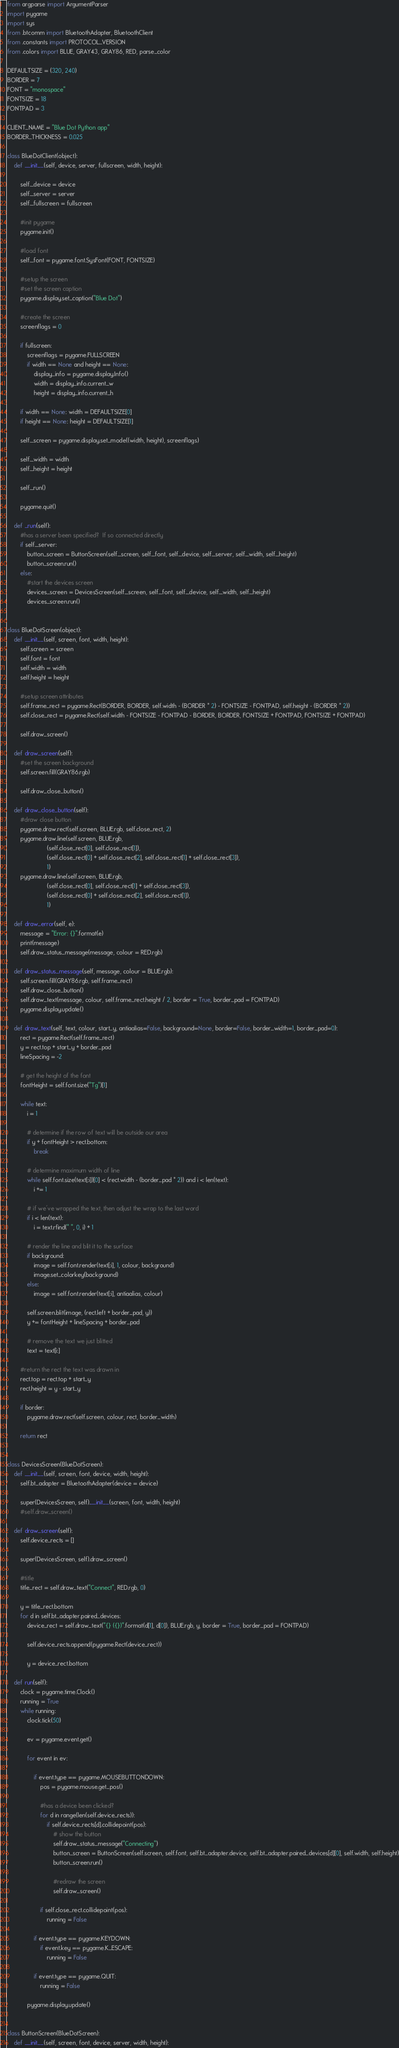Convert code to text. <code><loc_0><loc_0><loc_500><loc_500><_Python_>from argparse import ArgumentParser
import pygame
import sys
from .btcomm import BluetoothAdapter, BluetoothClient
from .constants import PROTOCOL_VERSION
from .colors import BLUE, GRAY43, GRAY86, RED, parse_color

DEFAULTSIZE = (320, 240)
BORDER = 7
FONT = "monospace"
FONTSIZE = 18
FONTPAD = 3

CLIENT_NAME = "Blue Dot Python app"
BORDER_THICKNESS = 0.025

class BlueDotClient(object):
    def __init__(self, device, server, fullscreen, width, height):

        self._device = device
        self._server = server
        self._fullscreen = fullscreen
        
        #init pygame
        pygame.init()

        #load font
        self._font = pygame.font.SysFont(FONT, FONTSIZE)

        #setup the screen
        #set the screen caption
        pygame.display.set_caption("Blue Dot")

        #create the screen
        screenflags = 0

        if fullscreen:
            screenflags = pygame.FULLSCREEN
            if width == None and height == None:
                display_info = pygame.display.Info()
                width = display_info.current_w
                height = display_info.current_h

        if width == None: width = DEFAULTSIZE[0]
        if height == None: height = DEFAULTSIZE[1]

        self._screen = pygame.display.set_mode((width, height), screenflags)

        self._width = width
        self._height = height

        self._run()

        pygame.quit()

    def _run(self):
        #has a server been specified?  If so connected directly
        if self._server:
            button_screen = ButtonScreen(self._screen, self._font, self._device, self._server, self._width, self._height)
            button_screen.run()
        else:
            #start the devices screen
            devices_screen = DevicesScreen(self._screen, self._font, self._device, self._width, self._height)
            devices_screen.run()


class BlueDotScreen(object):
    def __init__(self, screen, font, width, height):
        self.screen = screen
        self.font = font
        self.width = width
        self.height = height

        #setup screen attributes
        self.frame_rect = pygame.Rect(BORDER, BORDER, self.width - (BORDER * 2) - FONTSIZE - FONTPAD, self.height - (BORDER * 2))
        self.close_rect = pygame.Rect(self.width - FONTSIZE - FONTPAD - BORDER, BORDER, FONTSIZE + FONTPAD, FONTSIZE + FONTPAD)

        self.draw_screen()

    def draw_screen(self):
        #set the screen background
        self.screen.fill(GRAY86.rgb)

        self.draw_close_button()

    def draw_close_button(self):
        #draw close button
        pygame.draw.rect(self.screen, BLUE.rgb, self.close_rect, 2)
        pygame.draw.line(self.screen, BLUE.rgb,
                        (self.close_rect[0], self.close_rect[1]),
                        (self.close_rect[0] + self.close_rect[2], self.close_rect[1] + self.close_rect[3]),
                        1)
        pygame.draw.line(self.screen, BLUE.rgb,
                        (self.close_rect[0], self.close_rect[1] + self.close_rect[3]),
                        (self.close_rect[0] + self.close_rect[2], self.close_rect[1]),
                        1)

    def draw_error(self, e):
        message = "Error: {}".format(e)
        print(message)
        self.draw_status_message(message, colour = RED.rgb)

    def draw_status_message(self, message, colour = BLUE.rgb):
        self.screen.fill(GRAY86.rgb, self.frame_rect)
        self.draw_close_button()
        self.draw_text(message, colour, self.frame_rect.height / 2, border = True, border_pad = FONTPAD)
        pygame.display.update()

    def draw_text(self, text, colour, start_y, antiaalias=False, background=None, border=False, border_width=1, border_pad=0):
        rect = pygame.Rect(self.frame_rect)
        y = rect.top + start_y + border_pad
        lineSpacing = -2

        # get the height of the font
        fontHeight = self.font.size("Tg")[1]

        while text:
            i = 1

            # determine if the row of text will be outside our area
            if y + fontHeight > rect.bottom:
                break

            # determine maximum width of line
            while self.font.size(text[:i])[0] < (rect.width - (border_pad * 2)) and i < len(text):
                i += 1

            # if we've wrapped the text, then adjust the wrap to the last word
            if i < len(text):
                i = text.rfind(" ", 0, i) + 1

            # render the line and blit it to the surface
            if background:
                image = self.font.render(text[:i], 1, colour, background)
                image.set_colorkey(background)
            else:
                image = self.font.render(text[:i], antiaalias, colour)

            self.screen.blit(image, (rect.left + border_pad, y))
            y += fontHeight + lineSpacing + border_pad

            # remove the text we just blitted
            text = text[i:]

        #return the rect the text was drawn in
        rect.top = rect.top + start_y
        rect.height = y - start_y

        if border:
            pygame.draw.rect(self.screen, colour, rect, border_width)

        return rect


class DevicesScreen(BlueDotScreen):
    def __init__(self, screen, font, device, width, height):
        self.bt_adapter = BluetoothAdapter(device = device)

        super(DevicesScreen, self).__init__(screen, font, width, height)
        #self.draw_screen()

    def draw_screen(self):
        self.device_rects = []

        super(DevicesScreen, self).draw_screen()

        #title
        title_rect = self.draw_text("Connect", RED.rgb, 0)

        y = title_rect.bottom
        for d in self.bt_adapter.paired_devices:
            device_rect = self.draw_text("{} ({})".format(d[1], d[0]), BLUE.rgb, y, border = True, border_pad = FONTPAD)

            self.device_rects.append(pygame.Rect(device_rect))

            y = device_rect.bottom

    def run(self):
        clock = pygame.time.Clock()
        running = True
        while running:
            clock.tick(50)

            ev = pygame.event.get()

            for event in ev:

                if event.type == pygame.MOUSEBUTTONDOWN:
                    pos = pygame.mouse.get_pos()

                    #has a device been clicked?
                    for d in range(len(self.device_rects)):
                        if self.device_rects[d].collidepoint(pos):
                            # show the button
                            self.draw_status_message("Connecting")
                            button_screen = ButtonScreen(self.screen, self.font, self.bt_adapter.device, self.bt_adapter.paired_devices[d][0], self.width, self.height)
                            button_screen.run()

                            #redraw the screen
                            self.draw_screen()

                    if self.close_rect.collidepoint(pos):
                        running = False

                if event.type == pygame.KEYDOWN:
                    if event.key == pygame.K_ESCAPE:
                        running = False

                if event.type == pygame.QUIT:
                    running = False

            pygame.display.update()


class ButtonScreen(BlueDotScreen):
    def __init__(self, screen, font, device, server, width, height):        </code> 